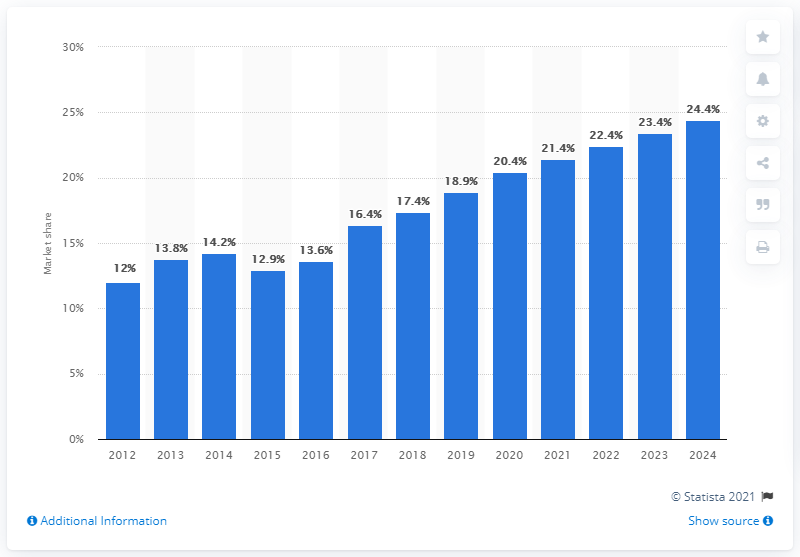Identify some key points in this picture. Este Lauder's share of the global makeup products market in 2018 was 17.4%. 